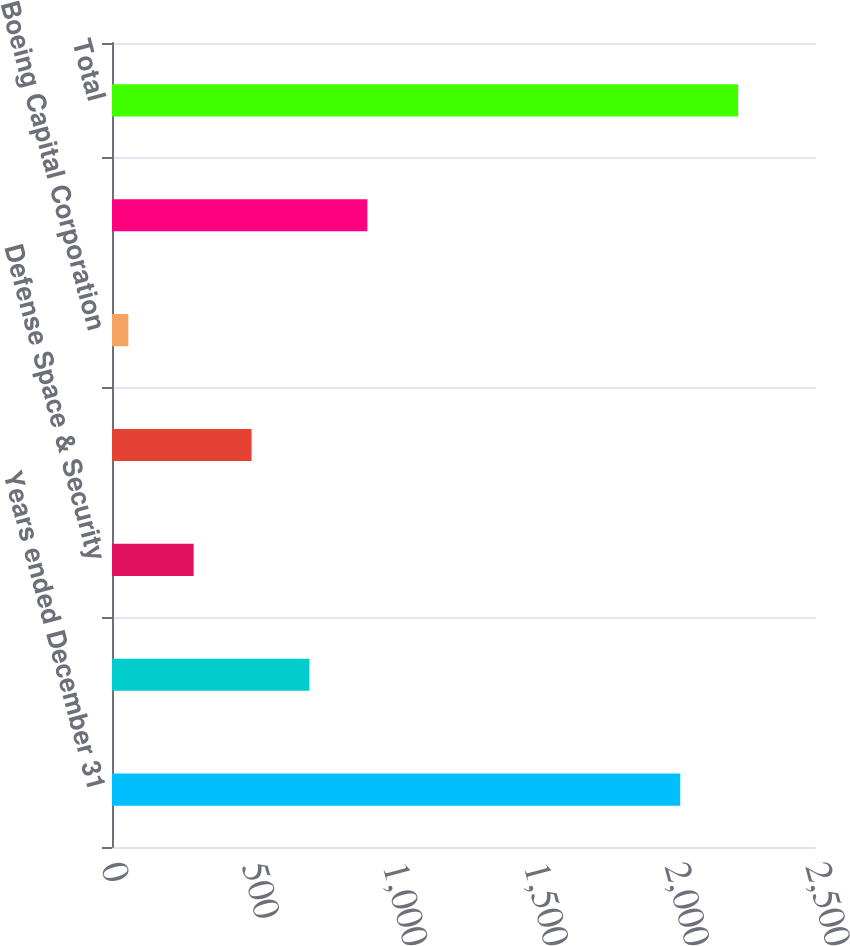Convert chart. <chart><loc_0><loc_0><loc_500><loc_500><bar_chart><fcel>Years ended December 31<fcel>Commercial Airplanes<fcel>Defense Space & Security<fcel>Global Services<fcel>Boeing Capital Corporation<fcel>Unallocated items eliminations<fcel>Total<nl><fcel>2018<fcel>701.2<fcel>290<fcel>495.6<fcel>58<fcel>906.8<fcel>2223.6<nl></chart> 